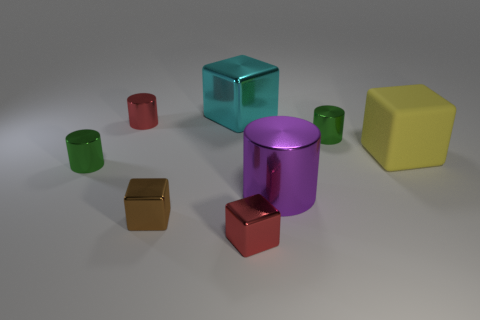There is a yellow thing that is the same shape as the brown object; what is its material?
Your response must be concise. Rubber. There is a tiny red metal object that is right of the large cyan metal block; is it the same shape as the green object behind the matte object?
Keep it short and to the point. No. Are there fewer large yellow rubber blocks that are right of the large cyan shiny thing than tiny metal things that are left of the tiny red metallic cube?
Offer a terse response. Yes. What shape is the large cyan thing that is the same material as the brown object?
Provide a short and direct response. Cube. There is a cylinder that is to the left of the large purple cylinder and in front of the big yellow matte block; what is its color?
Provide a succinct answer. Green. Do the tiny red thing that is in front of the purple object and the large cyan object have the same material?
Ensure brevity in your answer.  Yes. Is the number of red cubes behind the yellow cube less than the number of tiny cyan rubber spheres?
Ensure brevity in your answer.  No. Is there a green cylinder made of the same material as the cyan cube?
Your response must be concise. Yes. There is a brown block; is it the same size as the green shiny cylinder that is in front of the yellow thing?
Offer a terse response. Yes. Do the large cylinder and the tiny red cylinder have the same material?
Keep it short and to the point. Yes. 